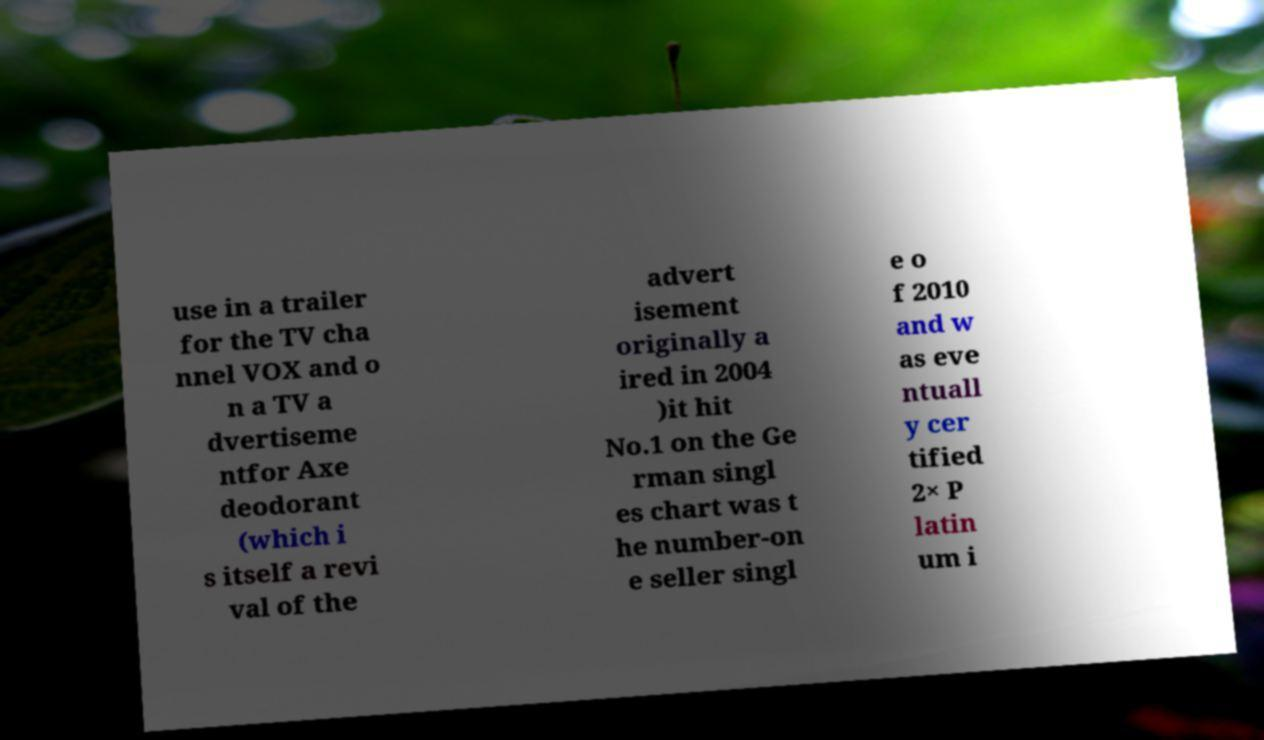Can you accurately transcribe the text from the provided image for me? use in a trailer for the TV cha nnel VOX and o n a TV a dvertiseme ntfor Axe deodorant (which i s itself a revi val of the advert isement originally a ired in 2004 )it hit No.1 on the Ge rman singl es chart was t he number-on e seller singl e o f 2010 and w as eve ntuall y cer tified 2× P latin um i 